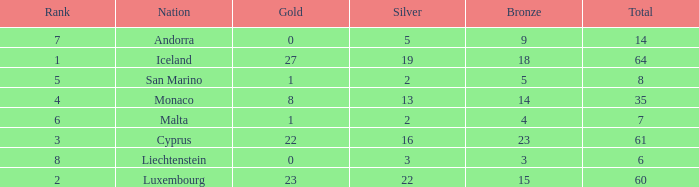How many bronzes for Iceland with over 2 silvers? 18.0. 